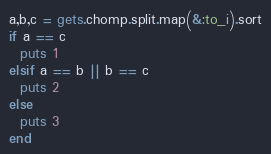Convert code to text. <code><loc_0><loc_0><loc_500><loc_500><_Ruby_>a,b,c = gets.chomp.split.map(&:to_i).sort
if a == c
  puts 1
elsif a == b || b == c
  puts 2
else
  puts 3
end</code> 